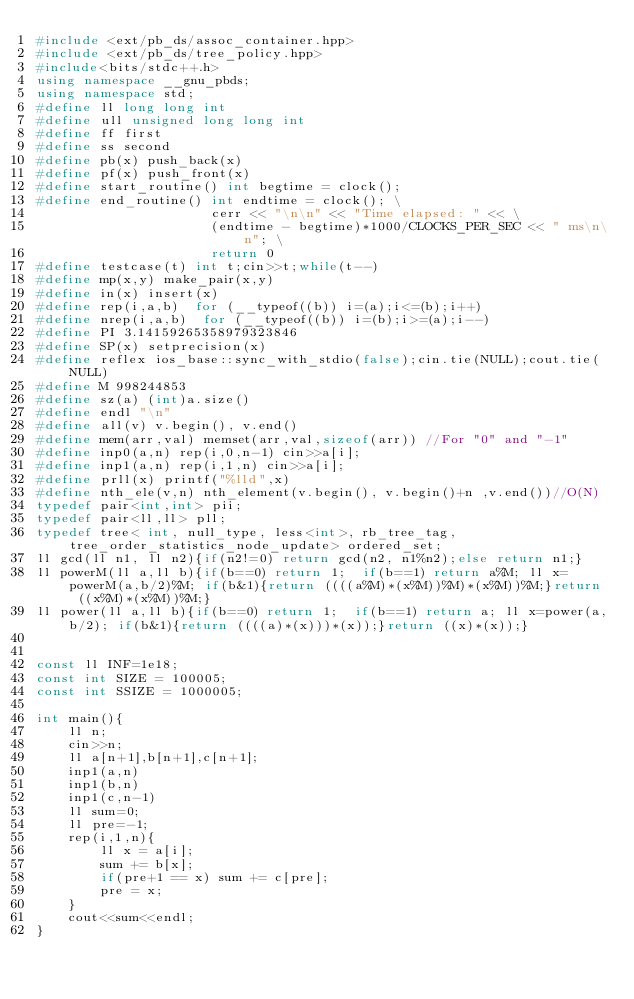Convert code to text. <code><loc_0><loc_0><loc_500><loc_500><_C++_>#include <ext/pb_ds/assoc_container.hpp>
#include <ext/pb_ds/tree_policy.hpp>
#include<bits/stdc++.h>
using namespace __gnu_pbds;
using namespace std;
#define ll long long int
#define ull unsigned long long int
#define ff first 
#define ss second
#define pb(x) push_back(x)
#define pf(x) push_front(x)
#define start_routine() int begtime = clock();
#define end_routine() int endtime = clock(); \
                      cerr << "\n\n" << "Time elapsed: " << \
                      (endtime - begtime)*1000/CLOCKS_PER_SEC << " ms\n\n"; \
                      return 0
#define testcase(t) int t;cin>>t;while(t--)
#define mp(x,y) make_pair(x,y)
#define in(x) insert(x)
#define rep(i,a,b)  for (__typeof((b)) i=(a);i<=(b);i++)
#define nrep(i,a,b)  for (__typeof((b)) i=(b);i>=(a);i--)
#define PI 3.14159265358979323846
#define SP(x) setprecision(x)
#define reflex ios_base::sync_with_stdio(false);cin.tie(NULL);cout.tie(NULL)
#define M 998244853
#define sz(a) (int)a.size()
#define endl "\n"
#define all(v) v.begin(), v.end()
#define mem(arr,val) memset(arr,val,sizeof(arr)) //For "0" and "-1"                  
#define inp0(a,n) rep(i,0,n-1) cin>>a[i];
#define inp1(a,n) rep(i,1,n) cin>>a[i]; 
#define prll(x) printf("%lld",x)
#define nth_ele(v,n) nth_element(v.begin(), v.begin()+n ,v.end())//O(N)
typedef pair<int,int> pii;
typedef pair<ll,ll> pll;
typedef tree< int, null_type, less<int>, rb_tree_tag, tree_order_statistics_node_update> ordered_set;
ll gcd(ll n1, ll n2){if(n2!=0) return gcd(n2, n1%n2);else return n1;}
ll powerM(ll a,ll b){if(b==0) return 1;  if(b==1) return a%M; ll x=powerM(a,b/2)%M; if(b&1){return ((((a%M)*(x%M))%M)*(x%M))%M;}return ((x%M)*(x%M))%M;}
ll power(ll a,ll b){if(b==0) return 1;  if(b==1) return a; ll x=power(a,b/2); if(b&1){return ((((a)*(x)))*(x));}return ((x)*(x));}
 

const ll INF=1e18; 
const int SIZE = 100005;
const int SSIZE = 1000005;

int main(){
    ll n;
    cin>>n;
    ll a[n+1],b[n+1],c[n+1];
    inp1(a,n)
    inp1(b,n)
    inp1(c,n-1)
    ll sum=0;
    ll pre=-1;
    rep(i,1,n){
        ll x = a[i];
        sum += b[x];
        if(pre+1 == x) sum += c[pre];
        pre = x;
    }
    cout<<sum<<endl;
}

</code> 